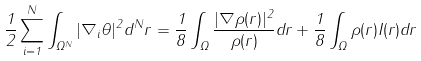Convert formula to latex. <formula><loc_0><loc_0><loc_500><loc_500>\frac { 1 } { 2 } \sum _ { i = 1 } ^ { N } \int _ { \Omega ^ { N } } | \nabla _ { i } \theta | ^ { 2 } d ^ { N } { r } = \frac { 1 } { 8 } \int _ { \Omega } \frac { | \nabla \rho ( { r } ) | ^ { 2 } } { \rho ( { r } ) } d { r } + \frac { 1 } { 8 } \int _ { \Omega } \rho ( { r } ) I ( { r } ) d { r }</formula> 